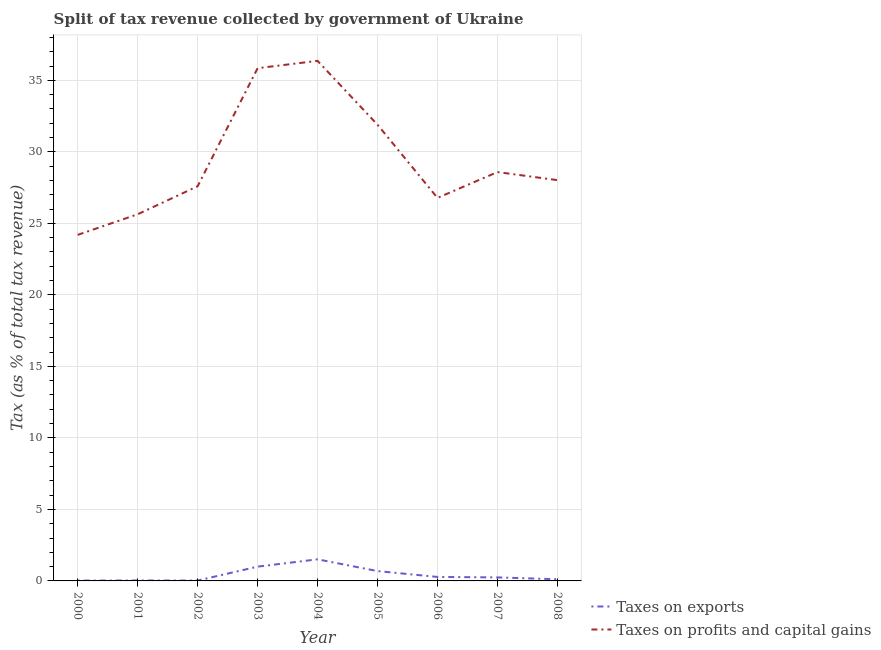How many different coloured lines are there?
Provide a succinct answer. 2. Does the line corresponding to percentage of revenue obtained from taxes on exports intersect with the line corresponding to percentage of revenue obtained from taxes on profits and capital gains?
Offer a very short reply. No. Is the number of lines equal to the number of legend labels?
Make the answer very short. Yes. What is the percentage of revenue obtained from taxes on profits and capital gains in 2002?
Give a very brief answer. 27.59. Across all years, what is the maximum percentage of revenue obtained from taxes on profits and capital gains?
Your response must be concise. 36.36. Across all years, what is the minimum percentage of revenue obtained from taxes on exports?
Your answer should be compact. 0.02. In which year was the percentage of revenue obtained from taxes on exports maximum?
Ensure brevity in your answer.  2004. What is the total percentage of revenue obtained from taxes on profits and capital gains in the graph?
Give a very brief answer. 264.93. What is the difference between the percentage of revenue obtained from taxes on profits and capital gains in 2004 and that in 2006?
Offer a terse response. 9.58. What is the difference between the percentage of revenue obtained from taxes on exports in 2005 and the percentage of revenue obtained from taxes on profits and capital gains in 2001?
Your answer should be compact. -24.95. What is the average percentage of revenue obtained from taxes on exports per year?
Your response must be concise. 0.44. In the year 2008, what is the difference between the percentage of revenue obtained from taxes on profits and capital gains and percentage of revenue obtained from taxes on exports?
Your response must be concise. 27.91. What is the ratio of the percentage of revenue obtained from taxes on exports in 2003 to that in 2005?
Provide a short and direct response. 1.45. Is the percentage of revenue obtained from taxes on exports in 2004 less than that in 2005?
Your response must be concise. No. Is the difference between the percentage of revenue obtained from taxes on profits and capital gains in 2000 and 2004 greater than the difference between the percentage of revenue obtained from taxes on exports in 2000 and 2004?
Provide a short and direct response. No. What is the difference between the highest and the second highest percentage of revenue obtained from taxes on profits and capital gains?
Make the answer very short. 0.51. What is the difference between the highest and the lowest percentage of revenue obtained from taxes on profits and capital gains?
Your answer should be compact. 12.17. In how many years, is the percentage of revenue obtained from taxes on exports greater than the average percentage of revenue obtained from taxes on exports taken over all years?
Provide a short and direct response. 3. Is the sum of the percentage of revenue obtained from taxes on profits and capital gains in 2004 and 2008 greater than the maximum percentage of revenue obtained from taxes on exports across all years?
Your answer should be very brief. Yes. Does the percentage of revenue obtained from taxes on profits and capital gains monotonically increase over the years?
Keep it short and to the point. No. How many years are there in the graph?
Ensure brevity in your answer.  9. Where does the legend appear in the graph?
Offer a terse response. Bottom right. How many legend labels are there?
Offer a terse response. 2. How are the legend labels stacked?
Give a very brief answer. Vertical. What is the title of the graph?
Provide a succinct answer. Split of tax revenue collected by government of Ukraine. What is the label or title of the X-axis?
Make the answer very short. Year. What is the label or title of the Y-axis?
Keep it short and to the point. Tax (as % of total tax revenue). What is the Tax (as % of total tax revenue) in Taxes on exports in 2000?
Give a very brief answer. 0.02. What is the Tax (as % of total tax revenue) of Taxes on profits and capital gains in 2000?
Your response must be concise. 24.2. What is the Tax (as % of total tax revenue) of Taxes on exports in 2001?
Give a very brief answer. 0.03. What is the Tax (as % of total tax revenue) in Taxes on profits and capital gains in 2001?
Provide a short and direct response. 25.64. What is the Tax (as % of total tax revenue) of Taxes on exports in 2002?
Give a very brief answer. 0.03. What is the Tax (as % of total tax revenue) in Taxes on profits and capital gains in 2002?
Provide a succinct answer. 27.59. What is the Tax (as % of total tax revenue) of Taxes on exports in 2003?
Ensure brevity in your answer.  1. What is the Tax (as % of total tax revenue) in Taxes on profits and capital gains in 2003?
Give a very brief answer. 35.85. What is the Tax (as % of total tax revenue) in Taxes on exports in 2004?
Your answer should be very brief. 1.51. What is the Tax (as % of total tax revenue) of Taxes on profits and capital gains in 2004?
Ensure brevity in your answer.  36.36. What is the Tax (as % of total tax revenue) of Taxes on exports in 2005?
Provide a succinct answer. 0.69. What is the Tax (as % of total tax revenue) of Taxes on profits and capital gains in 2005?
Make the answer very short. 31.9. What is the Tax (as % of total tax revenue) of Taxes on exports in 2006?
Your response must be concise. 0.28. What is the Tax (as % of total tax revenue) in Taxes on profits and capital gains in 2006?
Offer a terse response. 26.78. What is the Tax (as % of total tax revenue) in Taxes on exports in 2007?
Give a very brief answer. 0.25. What is the Tax (as % of total tax revenue) in Taxes on profits and capital gains in 2007?
Provide a succinct answer. 28.59. What is the Tax (as % of total tax revenue) in Taxes on exports in 2008?
Offer a very short reply. 0.12. What is the Tax (as % of total tax revenue) of Taxes on profits and capital gains in 2008?
Offer a very short reply. 28.02. Across all years, what is the maximum Tax (as % of total tax revenue) of Taxes on exports?
Give a very brief answer. 1.51. Across all years, what is the maximum Tax (as % of total tax revenue) of Taxes on profits and capital gains?
Your answer should be compact. 36.36. Across all years, what is the minimum Tax (as % of total tax revenue) of Taxes on exports?
Keep it short and to the point. 0.02. Across all years, what is the minimum Tax (as % of total tax revenue) in Taxes on profits and capital gains?
Make the answer very short. 24.2. What is the total Tax (as % of total tax revenue) in Taxes on exports in the graph?
Make the answer very short. 3.92. What is the total Tax (as % of total tax revenue) of Taxes on profits and capital gains in the graph?
Provide a short and direct response. 264.93. What is the difference between the Tax (as % of total tax revenue) in Taxes on exports in 2000 and that in 2001?
Keep it short and to the point. -0.01. What is the difference between the Tax (as % of total tax revenue) in Taxes on profits and capital gains in 2000 and that in 2001?
Offer a terse response. -1.44. What is the difference between the Tax (as % of total tax revenue) of Taxes on exports in 2000 and that in 2002?
Give a very brief answer. -0. What is the difference between the Tax (as % of total tax revenue) in Taxes on profits and capital gains in 2000 and that in 2002?
Give a very brief answer. -3.4. What is the difference between the Tax (as % of total tax revenue) in Taxes on exports in 2000 and that in 2003?
Your answer should be very brief. -0.97. What is the difference between the Tax (as % of total tax revenue) of Taxes on profits and capital gains in 2000 and that in 2003?
Provide a short and direct response. -11.65. What is the difference between the Tax (as % of total tax revenue) in Taxes on exports in 2000 and that in 2004?
Make the answer very short. -1.49. What is the difference between the Tax (as % of total tax revenue) in Taxes on profits and capital gains in 2000 and that in 2004?
Your answer should be very brief. -12.17. What is the difference between the Tax (as % of total tax revenue) of Taxes on exports in 2000 and that in 2005?
Give a very brief answer. -0.67. What is the difference between the Tax (as % of total tax revenue) of Taxes on profits and capital gains in 2000 and that in 2005?
Your answer should be compact. -7.7. What is the difference between the Tax (as % of total tax revenue) in Taxes on exports in 2000 and that in 2006?
Offer a terse response. -0.26. What is the difference between the Tax (as % of total tax revenue) of Taxes on profits and capital gains in 2000 and that in 2006?
Give a very brief answer. -2.58. What is the difference between the Tax (as % of total tax revenue) in Taxes on exports in 2000 and that in 2007?
Provide a succinct answer. -0.22. What is the difference between the Tax (as % of total tax revenue) of Taxes on profits and capital gains in 2000 and that in 2007?
Give a very brief answer. -4.39. What is the difference between the Tax (as % of total tax revenue) of Taxes on exports in 2000 and that in 2008?
Your answer should be very brief. -0.09. What is the difference between the Tax (as % of total tax revenue) of Taxes on profits and capital gains in 2000 and that in 2008?
Your response must be concise. -3.83. What is the difference between the Tax (as % of total tax revenue) of Taxes on exports in 2001 and that in 2002?
Provide a short and direct response. 0. What is the difference between the Tax (as % of total tax revenue) of Taxes on profits and capital gains in 2001 and that in 2002?
Give a very brief answer. -1.96. What is the difference between the Tax (as % of total tax revenue) of Taxes on exports in 2001 and that in 2003?
Your answer should be very brief. -0.97. What is the difference between the Tax (as % of total tax revenue) of Taxes on profits and capital gains in 2001 and that in 2003?
Provide a succinct answer. -10.21. What is the difference between the Tax (as % of total tax revenue) of Taxes on exports in 2001 and that in 2004?
Ensure brevity in your answer.  -1.48. What is the difference between the Tax (as % of total tax revenue) of Taxes on profits and capital gains in 2001 and that in 2004?
Make the answer very short. -10.73. What is the difference between the Tax (as % of total tax revenue) of Taxes on exports in 2001 and that in 2005?
Your response must be concise. -0.66. What is the difference between the Tax (as % of total tax revenue) of Taxes on profits and capital gains in 2001 and that in 2005?
Offer a very short reply. -6.26. What is the difference between the Tax (as % of total tax revenue) of Taxes on exports in 2001 and that in 2006?
Provide a succinct answer. -0.25. What is the difference between the Tax (as % of total tax revenue) in Taxes on profits and capital gains in 2001 and that in 2006?
Provide a short and direct response. -1.14. What is the difference between the Tax (as % of total tax revenue) in Taxes on exports in 2001 and that in 2007?
Ensure brevity in your answer.  -0.22. What is the difference between the Tax (as % of total tax revenue) in Taxes on profits and capital gains in 2001 and that in 2007?
Offer a very short reply. -2.95. What is the difference between the Tax (as % of total tax revenue) in Taxes on exports in 2001 and that in 2008?
Your answer should be compact. -0.09. What is the difference between the Tax (as % of total tax revenue) in Taxes on profits and capital gains in 2001 and that in 2008?
Make the answer very short. -2.39. What is the difference between the Tax (as % of total tax revenue) in Taxes on exports in 2002 and that in 2003?
Ensure brevity in your answer.  -0.97. What is the difference between the Tax (as % of total tax revenue) in Taxes on profits and capital gains in 2002 and that in 2003?
Offer a very short reply. -8.26. What is the difference between the Tax (as % of total tax revenue) of Taxes on exports in 2002 and that in 2004?
Make the answer very short. -1.48. What is the difference between the Tax (as % of total tax revenue) of Taxes on profits and capital gains in 2002 and that in 2004?
Keep it short and to the point. -8.77. What is the difference between the Tax (as % of total tax revenue) in Taxes on exports in 2002 and that in 2005?
Offer a very short reply. -0.66. What is the difference between the Tax (as % of total tax revenue) of Taxes on profits and capital gains in 2002 and that in 2005?
Provide a succinct answer. -4.3. What is the difference between the Tax (as % of total tax revenue) of Taxes on exports in 2002 and that in 2006?
Make the answer very short. -0.25. What is the difference between the Tax (as % of total tax revenue) in Taxes on profits and capital gains in 2002 and that in 2006?
Make the answer very short. 0.81. What is the difference between the Tax (as % of total tax revenue) in Taxes on exports in 2002 and that in 2007?
Your answer should be very brief. -0.22. What is the difference between the Tax (as % of total tax revenue) of Taxes on profits and capital gains in 2002 and that in 2007?
Keep it short and to the point. -0.99. What is the difference between the Tax (as % of total tax revenue) of Taxes on exports in 2002 and that in 2008?
Give a very brief answer. -0.09. What is the difference between the Tax (as % of total tax revenue) of Taxes on profits and capital gains in 2002 and that in 2008?
Provide a succinct answer. -0.43. What is the difference between the Tax (as % of total tax revenue) of Taxes on exports in 2003 and that in 2004?
Provide a short and direct response. -0.51. What is the difference between the Tax (as % of total tax revenue) in Taxes on profits and capital gains in 2003 and that in 2004?
Your answer should be compact. -0.51. What is the difference between the Tax (as % of total tax revenue) in Taxes on exports in 2003 and that in 2005?
Your response must be concise. 0.31. What is the difference between the Tax (as % of total tax revenue) in Taxes on profits and capital gains in 2003 and that in 2005?
Give a very brief answer. 3.95. What is the difference between the Tax (as % of total tax revenue) of Taxes on exports in 2003 and that in 2006?
Provide a succinct answer. 0.72. What is the difference between the Tax (as % of total tax revenue) in Taxes on profits and capital gains in 2003 and that in 2006?
Your answer should be compact. 9.07. What is the difference between the Tax (as % of total tax revenue) in Taxes on exports in 2003 and that in 2007?
Your answer should be compact. 0.75. What is the difference between the Tax (as % of total tax revenue) in Taxes on profits and capital gains in 2003 and that in 2007?
Offer a terse response. 7.26. What is the difference between the Tax (as % of total tax revenue) in Taxes on exports in 2003 and that in 2008?
Ensure brevity in your answer.  0.88. What is the difference between the Tax (as % of total tax revenue) in Taxes on profits and capital gains in 2003 and that in 2008?
Offer a very short reply. 7.83. What is the difference between the Tax (as % of total tax revenue) of Taxes on exports in 2004 and that in 2005?
Provide a short and direct response. 0.82. What is the difference between the Tax (as % of total tax revenue) of Taxes on profits and capital gains in 2004 and that in 2005?
Your answer should be very brief. 4.47. What is the difference between the Tax (as % of total tax revenue) in Taxes on exports in 2004 and that in 2006?
Your response must be concise. 1.23. What is the difference between the Tax (as % of total tax revenue) of Taxes on profits and capital gains in 2004 and that in 2006?
Offer a very short reply. 9.58. What is the difference between the Tax (as % of total tax revenue) of Taxes on exports in 2004 and that in 2007?
Your answer should be very brief. 1.26. What is the difference between the Tax (as % of total tax revenue) of Taxes on profits and capital gains in 2004 and that in 2007?
Offer a very short reply. 7.78. What is the difference between the Tax (as % of total tax revenue) of Taxes on exports in 2004 and that in 2008?
Your answer should be compact. 1.39. What is the difference between the Tax (as % of total tax revenue) of Taxes on profits and capital gains in 2004 and that in 2008?
Offer a very short reply. 8.34. What is the difference between the Tax (as % of total tax revenue) of Taxes on exports in 2005 and that in 2006?
Your response must be concise. 0.41. What is the difference between the Tax (as % of total tax revenue) of Taxes on profits and capital gains in 2005 and that in 2006?
Your response must be concise. 5.12. What is the difference between the Tax (as % of total tax revenue) of Taxes on exports in 2005 and that in 2007?
Ensure brevity in your answer.  0.44. What is the difference between the Tax (as % of total tax revenue) of Taxes on profits and capital gains in 2005 and that in 2007?
Keep it short and to the point. 3.31. What is the difference between the Tax (as % of total tax revenue) in Taxes on exports in 2005 and that in 2008?
Provide a short and direct response. 0.57. What is the difference between the Tax (as % of total tax revenue) in Taxes on profits and capital gains in 2005 and that in 2008?
Your answer should be compact. 3.87. What is the difference between the Tax (as % of total tax revenue) of Taxes on exports in 2006 and that in 2007?
Your response must be concise. 0.03. What is the difference between the Tax (as % of total tax revenue) in Taxes on profits and capital gains in 2006 and that in 2007?
Keep it short and to the point. -1.81. What is the difference between the Tax (as % of total tax revenue) in Taxes on exports in 2006 and that in 2008?
Your answer should be very brief. 0.16. What is the difference between the Tax (as % of total tax revenue) of Taxes on profits and capital gains in 2006 and that in 2008?
Provide a succinct answer. -1.24. What is the difference between the Tax (as % of total tax revenue) in Taxes on exports in 2007 and that in 2008?
Give a very brief answer. 0.13. What is the difference between the Tax (as % of total tax revenue) of Taxes on profits and capital gains in 2007 and that in 2008?
Your answer should be very brief. 0.56. What is the difference between the Tax (as % of total tax revenue) in Taxes on exports in 2000 and the Tax (as % of total tax revenue) in Taxes on profits and capital gains in 2001?
Your answer should be very brief. -25.61. What is the difference between the Tax (as % of total tax revenue) in Taxes on exports in 2000 and the Tax (as % of total tax revenue) in Taxes on profits and capital gains in 2002?
Your response must be concise. -27.57. What is the difference between the Tax (as % of total tax revenue) in Taxes on exports in 2000 and the Tax (as % of total tax revenue) in Taxes on profits and capital gains in 2003?
Ensure brevity in your answer.  -35.83. What is the difference between the Tax (as % of total tax revenue) in Taxes on exports in 2000 and the Tax (as % of total tax revenue) in Taxes on profits and capital gains in 2004?
Provide a succinct answer. -36.34. What is the difference between the Tax (as % of total tax revenue) of Taxes on exports in 2000 and the Tax (as % of total tax revenue) of Taxes on profits and capital gains in 2005?
Your response must be concise. -31.87. What is the difference between the Tax (as % of total tax revenue) of Taxes on exports in 2000 and the Tax (as % of total tax revenue) of Taxes on profits and capital gains in 2006?
Your response must be concise. -26.76. What is the difference between the Tax (as % of total tax revenue) of Taxes on exports in 2000 and the Tax (as % of total tax revenue) of Taxes on profits and capital gains in 2007?
Offer a terse response. -28.56. What is the difference between the Tax (as % of total tax revenue) in Taxes on exports in 2000 and the Tax (as % of total tax revenue) in Taxes on profits and capital gains in 2008?
Ensure brevity in your answer.  -28. What is the difference between the Tax (as % of total tax revenue) in Taxes on exports in 2001 and the Tax (as % of total tax revenue) in Taxes on profits and capital gains in 2002?
Offer a terse response. -27.56. What is the difference between the Tax (as % of total tax revenue) of Taxes on exports in 2001 and the Tax (as % of total tax revenue) of Taxes on profits and capital gains in 2003?
Give a very brief answer. -35.82. What is the difference between the Tax (as % of total tax revenue) in Taxes on exports in 2001 and the Tax (as % of total tax revenue) in Taxes on profits and capital gains in 2004?
Ensure brevity in your answer.  -36.33. What is the difference between the Tax (as % of total tax revenue) of Taxes on exports in 2001 and the Tax (as % of total tax revenue) of Taxes on profits and capital gains in 2005?
Make the answer very short. -31.87. What is the difference between the Tax (as % of total tax revenue) in Taxes on exports in 2001 and the Tax (as % of total tax revenue) in Taxes on profits and capital gains in 2006?
Your answer should be compact. -26.75. What is the difference between the Tax (as % of total tax revenue) in Taxes on exports in 2001 and the Tax (as % of total tax revenue) in Taxes on profits and capital gains in 2007?
Ensure brevity in your answer.  -28.56. What is the difference between the Tax (as % of total tax revenue) of Taxes on exports in 2001 and the Tax (as % of total tax revenue) of Taxes on profits and capital gains in 2008?
Your response must be concise. -27.99. What is the difference between the Tax (as % of total tax revenue) of Taxes on exports in 2002 and the Tax (as % of total tax revenue) of Taxes on profits and capital gains in 2003?
Your answer should be compact. -35.82. What is the difference between the Tax (as % of total tax revenue) of Taxes on exports in 2002 and the Tax (as % of total tax revenue) of Taxes on profits and capital gains in 2004?
Your answer should be compact. -36.34. What is the difference between the Tax (as % of total tax revenue) of Taxes on exports in 2002 and the Tax (as % of total tax revenue) of Taxes on profits and capital gains in 2005?
Your answer should be very brief. -31.87. What is the difference between the Tax (as % of total tax revenue) in Taxes on exports in 2002 and the Tax (as % of total tax revenue) in Taxes on profits and capital gains in 2006?
Offer a very short reply. -26.75. What is the difference between the Tax (as % of total tax revenue) in Taxes on exports in 2002 and the Tax (as % of total tax revenue) in Taxes on profits and capital gains in 2007?
Your answer should be compact. -28.56. What is the difference between the Tax (as % of total tax revenue) of Taxes on exports in 2002 and the Tax (as % of total tax revenue) of Taxes on profits and capital gains in 2008?
Make the answer very short. -28. What is the difference between the Tax (as % of total tax revenue) in Taxes on exports in 2003 and the Tax (as % of total tax revenue) in Taxes on profits and capital gains in 2004?
Offer a very short reply. -35.36. What is the difference between the Tax (as % of total tax revenue) of Taxes on exports in 2003 and the Tax (as % of total tax revenue) of Taxes on profits and capital gains in 2005?
Provide a succinct answer. -30.9. What is the difference between the Tax (as % of total tax revenue) in Taxes on exports in 2003 and the Tax (as % of total tax revenue) in Taxes on profits and capital gains in 2006?
Make the answer very short. -25.78. What is the difference between the Tax (as % of total tax revenue) of Taxes on exports in 2003 and the Tax (as % of total tax revenue) of Taxes on profits and capital gains in 2007?
Your response must be concise. -27.59. What is the difference between the Tax (as % of total tax revenue) in Taxes on exports in 2003 and the Tax (as % of total tax revenue) in Taxes on profits and capital gains in 2008?
Your answer should be compact. -27.03. What is the difference between the Tax (as % of total tax revenue) of Taxes on exports in 2004 and the Tax (as % of total tax revenue) of Taxes on profits and capital gains in 2005?
Your answer should be very brief. -30.39. What is the difference between the Tax (as % of total tax revenue) in Taxes on exports in 2004 and the Tax (as % of total tax revenue) in Taxes on profits and capital gains in 2006?
Provide a succinct answer. -25.27. What is the difference between the Tax (as % of total tax revenue) in Taxes on exports in 2004 and the Tax (as % of total tax revenue) in Taxes on profits and capital gains in 2007?
Provide a succinct answer. -27.08. What is the difference between the Tax (as % of total tax revenue) in Taxes on exports in 2004 and the Tax (as % of total tax revenue) in Taxes on profits and capital gains in 2008?
Offer a very short reply. -26.51. What is the difference between the Tax (as % of total tax revenue) of Taxes on exports in 2005 and the Tax (as % of total tax revenue) of Taxes on profits and capital gains in 2006?
Offer a terse response. -26.09. What is the difference between the Tax (as % of total tax revenue) of Taxes on exports in 2005 and the Tax (as % of total tax revenue) of Taxes on profits and capital gains in 2007?
Offer a very short reply. -27.9. What is the difference between the Tax (as % of total tax revenue) in Taxes on exports in 2005 and the Tax (as % of total tax revenue) in Taxes on profits and capital gains in 2008?
Offer a very short reply. -27.33. What is the difference between the Tax (as % of total tax revenue) in Taxes on exports in 2006 and the Tax (as % of total tax revenue) in Taxes on profits and capital gains in 2007?
Provide a short and direct response. -28.31. What is the difference between the Tax (as % of total tax revenue) of Taxes on exports in 2006 and the Tax (as % of total tax revenue) of Taxes on profits and capital gains in 2008?
Your response must be concise. -27.74. What is the difference between the Tax (as % of total tax revenue) of Taxes on exports in 2007 and the Tax (as % of total tax revenue) of Taxes on profits and capital gains in 2008?
Your answer should be very brief. -27.78. What is the average Tax (as % of total tax revenue) of Taxes on exports per year?
Your answer should be very brief. 0.44. What is the average Tax (as % of total tax revenue) in Taxes on profits and capital gains per year?
Give a very brief answer. 29.44. In the year 2000, what is the difference between the Tax (as % of total tax revenue) in Taxes on exports and Tax (as % of total tax revenue) in Taxes on profits and capital gains?
Provide a succinct answer. -24.17. In the year 2001, what is the difference between the Tax (as % of total tax revenue) of Taxes on exports and Tax (as % of total tax revenue) of Taxes on profits and capital gains?
Your response must be concise. -25.61. In the year 2002, what is the difference between the Tax (as % of total tax revenue) in Taxes on exports and Tax (as % of total tax revenue) in Taxes on profits and capital gains?
Your response must be concise. -27.57. In the year 2003, what is the difference between the Tax (as % of total tax revenue) in Taxes on exports and Tax (as % of total tax revenue) in Taxes on profits and capital gains?
Your response must be concise. -34.85. In the year 2004, what is the difference between the Tax (as % of total tax revenue) in Taxes on exports and Tax (as % of total tax revenue) in Taxes on profits and capital gains?
Your response must be concise. -34.85. In the year 2005, what is the difference between the Tax (as % of total tax revenue) of Taxes on exports and Tax (as % of total tax revenue) of Taxes on profits and capital gains?
Provide a succinct answer. -31.21. In the year 2006, what is the difference between the Tax (as % of total tax revenue) of Taxes on exports and Tax (as % of total tax revenue) of Taxes on profits and capital gains?
Ensure brevity in your answer.  -26.5. In the year 2007, what is the difference between the Tax (as % of total tax revenue) of Taxes on exports and Tax (as % of total tax revenue) of Taxes on profits and capital gains?
Give a very brief answer. -28.34. In the year 2008, what is the difference between the Tax (as % of total tax revenue) of Taxes on exports and Tax (as % of total tax revenue) of Taxes on profits and capital gains?
Make the answer very short. -27.91. What is the ratio of the Tax (as % of total tax revenue) in Taxes on exports in 2000 to that in 2001?
Provide a succinct answer. 0.78. What is the ratio of the Tax (as % of total tax revenue) of Taxes on profits and capital gains in 2000 to that in 2001?
Offer a very short reply. 0.94. What is the ratio of the Tax (as % of total tax revenue) of Taxes on exports in 2000 to that in 2002?
Provide a succinct answer. 0.89. What is the ratio of the Tax (as % of total tax revenue) of Taxes on profits and capital gains in 2000 to that in 2002?
Your response must be concise. 0.88. What is the ratio of the Tax (as % of total tax revenue) of Taxes on exports in 2000 to that in 2003?
Offer a terse response. 0.02. What is the ratio of the Tax (as % of total tax revenue) in Taxes on profits and capital gains in 2000 to that in 2003?
Offer a very short reply. 0.67. What is the ratio of the Tax (as % of total tax revenue) of Taxes on exports in 2000 to that in 2004?
Make the answer very short. 0.02. What is the ratio of the Tax (as % of total tax revenue) in Taxes on profits and capital gains in 2000 to that in 2004?
Make the answer very short. 0.67. What is the ratio of the Tax (as % of total tax revenue) of Taxes on exports in 2000 to that in 2005?
Your response must be concise. 0.03. What is the ratio of the Tax (as % of total tax revenue) in Taxes on profits and capital gains in 2000 to that in 2005?
Offer a terse response. 0.76. What is the ratio of the Tax (as % of total tax revenue) in Taxes on exports in 2000 to that in 2006?
Provide a succinct answer. 0.08. What is the ratio of the Tax (as % of total tax revenue) in Taxes on profits and capital gains in 2000 to that in 2006?
Offer a terse response. 0.9. What is the ratio of the Tax (as % of total tax revenue) of Taxes on exports in 2000 to that in 2007?
Your answer should be compact. 0.1. What is the ratio of the Tax (as % of total tax revenue) of Taxes on profits and capital gains in 2000 to that in 2007?
Make the answer very short. 0.85. What is the ratio of the Tax (as % of total tax revenue) in Taxes on exports in 2000 to that in 2008?
Offer a terse response. 0.2. What is the ratio of the Tax (as % of total tax revenue) in Taxes on profits and capital gains in 2000 to that in 2008?
Ensure brevity in your answer.  0.86. What is the ratio of the Tax (as % of total tax revenue) in Taxes on exports in 2001 to that in 2002?
Provide a short and direct response. 1.14. What is the ratio of the Tax (as % of total tax revenue) in Taxes on profits and capital gains in 2001 to that in 2002?
Your answer should be compact. 0.93. What is the ratio of the Tax (as % of total tax revenue) of Taxes on exports in 2001 to that in 2003?
Provide a short and direct response. 0.03. What is the ratio of the Tax (as % of total tax revenue) of Taxes on profits and capital gains in 2001 to that in 2003?
Offer a terse response. 0.72. What is the ratio of the Tax (as % of total tax revenue) of Taxes on exports in 2001 to that in 2004?
Keep it short and to the point. 0.02. What is the ratio of the Tax (as % of total tax revenue) of Taxes on profits and capital gains in 2001 to that in 2004?
Provide a short and direct response. 0.7. What is the ratio of the Tax (as % of total tax revenue) in Taxes on exports in 2001 to that in 2005?
Provide a succinct answer. 0.04. What is the ratio of the Tax (as % of total tax revenue) in Taxes on profits and capital gains in 2001 to that in 2005?
Give a very brief answer. 0.8. What is the ratio of the Tax (as % of total tax revenue) in Taxes on exports in 2001 to that in 2006?
Give a very brief answer. 0.11. What is the ratio of the Tax (as % of total tax revenue) in Taxes on profits and capital gains in 2001 to that in 2006?
Ensure brevity in your answer.  0.96. What is the ratio of the Tax (as % of total tax revenue) of Taxes on exports in 2001 to that in 2007?
Offer a very short reply. 0.12. What is the ratio of the Tax (as % of total tax revenue) of Taxes on profits and capital gains in 2001 to that in 2007?
Offer a very short reply. 0.9. What is the ratio of the Tax (as % of total tax revenue) in Taxes on exports in 2001 to that in 2008?
Your answer should be compact. 0.26. What is the ratio of the Tax (as % of total tax revenue) of Taxes on profits and capital gains in 2001 to that in 2008?
Your answer should be very brief. 0.91. What is the ratio of the Tax (as % of total tax revenue) in Taxes on exports in 2002 to that in 2003?
Provide a short and direct response. 0.03. What is the ratio of the Tax (as % of total tax revenue) in Taxes on profits and capital gains in 2002 to that in 2003?
Ensure brevity in your answer.  0.77. What is the ratio of the Tax (as % of total tax revenue) of Taxes on exports in 2002 to that in 2004?
Provide a short and direct response. 0.02. What is the ratio of the Tax (as % of total tax revenue) of Taxes on profits and capital gains in 2002 to that in 2004?
Keep it short and to the point. 0.76. What is the ratio of the Tax (as % of total tax revenue) in Taxes on exports in 2002 to that in 2005?
Provide a short and direct response. 0.04. What is the ratio of the Tax (as % of total tax revenue) of Taxes on profits and capital gains in 2002 to that in 2005?
Offer a very short reply. 0.87. What is the ratio of the Tax (as % of total tax revenue) of Taxes on exports in 2002 to that in 2006?
Ensure brevity in your answer.  0.09. What is the ratio of the Tax (as % of total tax revenue) of Taxes on profits and capital gains in 2002 to that in 2006?
Your response must be concise. 1.03. What is the ratio of the Tax (as % of total tax revenue) in Taxes on exports in 2002 to that in 2007?
Ensure brevity in your answer.  0.11. What is the ratio of the Tax (as % of total tax revenue) in Taxes on profits and capital gains in 2002 to that in 2007?
Offer a terse response. 0.97. What is the ratio of the Tax (as % of total tax revenue) in Taxes on exports in 2002 to that in 2008?
Your answer should be compact. 0.23. What is the ratio of the Tax (as % of total tax revenue) in Taxes on profits and capital gains in 2002 to that in 2008?
Your response must be concise. 0.98. What is the ratio of the Tax (as % of total tax revenue) in Taxes on exports in 2003 to that in 2004?
Make the answer very short. 0.66. What is the ratio of the Tax (as % of total tax revenue) of Taxes on profits and capital gains in 2003 to that in 2004?
Provide a short and direct response. 0.99. What is the ratio of the Tax (as % of total tax revenue) in Taxes on exports in 2003 to that in 2005?
Your answer should be compact. 1.45. What is the ratio of the Tax (as % of total tax revenue) of Taxes on profits and capital gains in 2003 to that in 2005?
Your response must be concise. 1.12. What is the ratio of the Tax (as % of total tax revenue) in Taxes on exports in 2003 to that in 2006?
Your response must be concise. 3.57. What is the ratio of the Tax (as % of total tax revenue) of Taxes on profits and capital gains in 2003 to that in 2006?
Offer a very short reply. 1.34. What is the ratio of the Tax (as % of total tax revenue) of Taxes on exports in 2003 to that in 2007?
Your response must be concise. 4.07. What is the ratio of the Tax (as % of total tax revenue) of Taxes on profits and capital gains in 2003 to that in 2007?
Give a very brief answer. 1.25. What is the ratio of the Tax (as % of total tax revenue) in Taxes on exports in 2003 to that in 2008?
Give a very brief answer. 8.56. What is the ratio of the Tax (as % of total tax revenue) in Taxes on profits and capital gains in 2003 to that in 2008?
Offer a terse response. 1.28. What is the ratio of the Tax (as % of total tax revenue) in Taxes on exports in 2004 to that in 2005?
Offer a very short reply. 2.19. What is the ratio of the Tax (as % of total tax revenue) of Taxes on profits and capital gains in 2004 to that in 2005?
Your answer should be compact. 1.14. What is the ratio of the Tax (as % of total tax revenue) of Taxes on exports in 2004 to that in 2006?
Offer a very short reply. 5.4. What is the ratio of the Tax (as % of total tax revenue) of Taxes on profits and capital gains in 2004 to that in 2006?
Offer a terse response. 1.36. What is the ratio of the Tax (as % of total tax revenue) of Taxes on exports in 2004 to that in 2007?
Provide a succinct answer. 6.15. What is the ratio of the Tax (as % of total tax revenue) in Taxes on profits and capital gains in 2004 to that in 2007?
Provide a short and direct response. 1.27. What is the ratio of the Tax (as % of total tax revenue) in Taxes on exports in 2004 to that in 2008?
Offer a terse response. 12.95. What is the ratio of the Tax (as % of total tax revenue) in Taxes on profits and capital gains in 2004 to that in 2008?
Provide a succinct answer. 1.3. What is the ratio of the Tax (as % of total tax revenue) of Taxes on exports in 2005 to that in 2006?
Keep it short and to the point. 2.46. What is the ratio of the Tax (as % of total tax revenue) in Taxes on profits and capital gains in 2005 to that in 2006?
Your answer should be very brief. 1.19. What is the ratio of the Tax (as % of total tax revenue) of Taxes on exports in 2005 to that in 2007?
Make the answer very short. 2.81. What is the ratio of the Tax (as % of total tax revenue) of Taxes on profits and capital gains in 2005 to that in 2007?
Your answer should be compact. 1.12. What is the ratio of the Tax (as % of total tax revenue) of Taxes on exports in 2005 to that in 2008?
Keep it short and to the point. 5.91. What is the ratio of the Tax (as % of total tax revenue) in Taxes on profits and capital gains in 2005 to that in 2008?
Your response must be concise. 1.14. What is the ratio of the Tax (as % of total tax revenue) of Taxes on exports in 2006 to that in 2007?
Keep it short and to the point. 1.14. What is the ratio of the Tax (as % of total tax revenue) of Taxes on profits and capital gains in 2006 to that in 2007?
Keep it short and to the point. 0.94. What is the ratio of the Tax (as % of total tax revenue) of Taxes on exports in 2006 to that in 2008?
Offer a very short reply. 2.4. What is the ratio of the Tax (as % of total tax revenue) of Taxes on profits and capital gains in 2006 to that in 2008?
Provide a short and direct response. 0.96. What is the ratio of the Tax (as % of total tax revenue) of Taxes on exports in 2007 to that in 2008?
Your answer should be very brief. 2.1. What is the ratio of the Tax (as % of total tax revenue) of Taxes on profits and capital gains in 2007 to that in 2008?
Provide a short and direct response. 1.02. What is the difference between the highest and the second highest Tax (as % of total tax revenue) of Taxes on exports?
Your answer should be very brief. 0.51. What is the difference between the highest and the second highest Tax (as % of total tax revenue) of Taxes on profits and capital gains?
Give a very brief answer. 0.51. What is the difference between the highest and the lowest Tax (as % of total tax revenue) in Taxes on exports?
Provide a succinct answer. 1.49. What is the difference between the highest and the lowest Tax (as % of total tax revenue) in Taxes on profits and capital gains?
Provide a short and direct response. 12.17. 